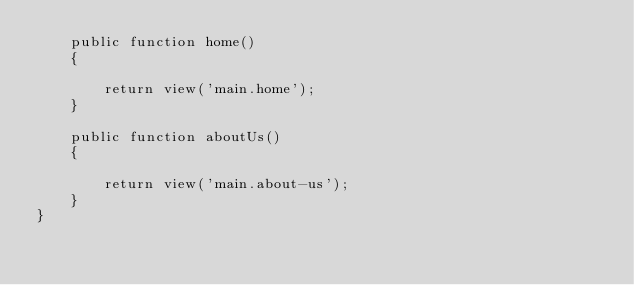<code> <loc_0><loc_0><loc_500><loc_500><_PHP_>    public function home()
    {

        return view('main.home');
    }

    public function aboutUs()
    {

        return view('main.about-us');
    }
}
</code> 